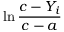<formula> <loc_0><loc_0><loc_500><loc_500>\ln { \frac { c - Y _ { i } } { c - a } }</formula> 